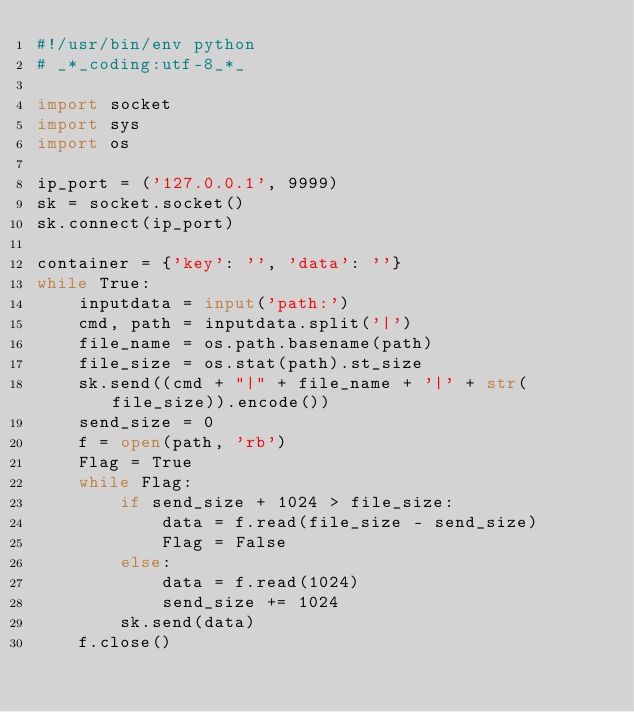<code> <loc_0><loc_0><loc_500><loc_500><_Python_>#!/usr/bin/env python
# _*_coding:utf-8_*_

import socket
import sys
import os

ip_port = ('127.0.0.1', 9999)
sk = socket.socket()
sk.connect(ip_port)

container = {'key': '', 'data': ''}
while True:
    inputdata = input('path:')
    cmd, path = inputdata.split('|')
    file_name = os.path.basename(path)
    file_size = os.stat(path).st_size
    sk.send((cmd + "|" + file_name + '|' + str(file_size)).encode())
    send_size = 0
    f = open(path, 'rb')
    Flag = True
    while Flag:
        if send_size + 1024 > file_size:
            data = f.read(file_size - send_size)
            Flag = False
        else:
            data = f.read(1024)
            send_size += 1024
        sk.send(data)
    f.close()


</code> 